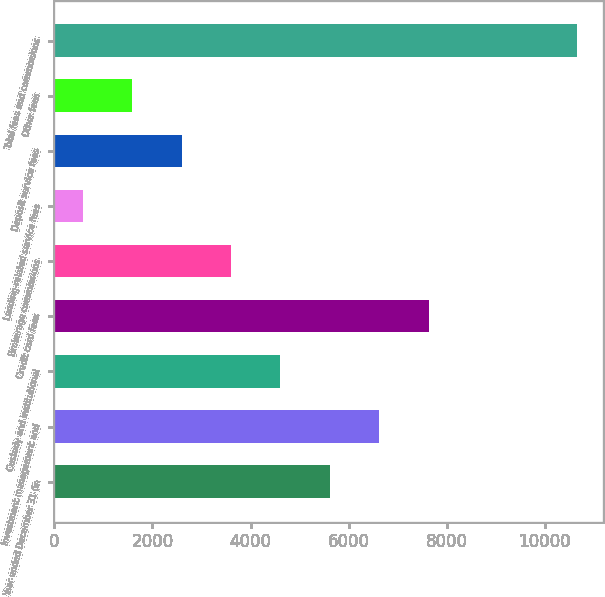<chart> <loc_0><loc_0><loc_500><loc_500><bar_chart><fcel>Year ended December 31 (in<fcel>Investment management and<fcel>Custody and institutional<fcel>Credit card fees<fcel>Brokerage commissions<fcel>Lending-related service fees<fcel>Deposit service fees<fcel>Other fees<fcel>Total fees and commissions<nl><fcel>5616<fcel>6623.2<fcel>4608.8<fcel>7630.4<fcel>3601.6<fcel>580<fcel>2594.4<fcel>1587.2<fcel>10652<nl></chart> 